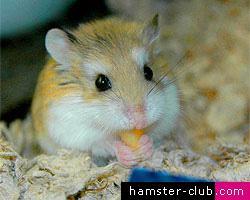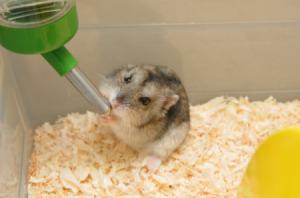The first image is the image on the left, the second image is the image on the right. Considering the images on both sides, is "A hamster is eating off a clear bowl full of food." valid? Answer yes or no. No. The first image is the image on the left, the second image is the image on the right. For the images shown, is this caption "An image shows an orange-and-white hamster next to a clear bowl of food." true? Answer yes or no. No. 